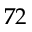<formula> <loc_0><loc_0><loc_500><loc_500>7 2</formula> 